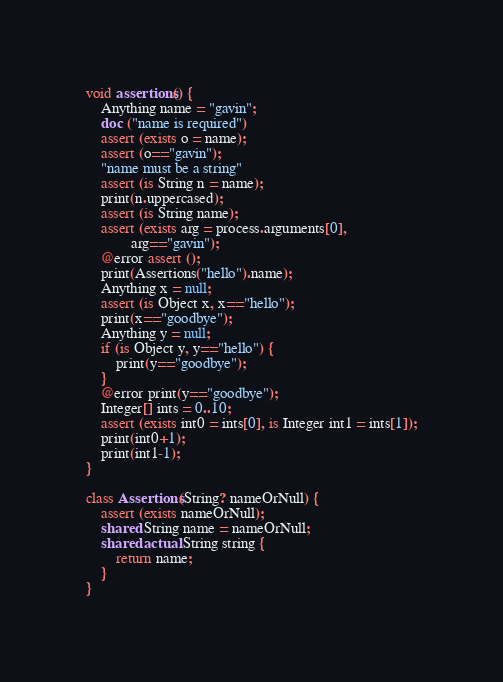<code> <loc_0><loc_0><loc_500><loc_500><_Ceylon_>void assertions() {
    Anything name = "gavin";
    doc ("name is required") 
    assert (exists o = name);
    assert (o=="gavin");
    "name must be a string"
    assert (is String n = name);
    print(n.uppercased);
    assert (is String name);
    assert (exists arg = process.arguments[0], 
            arg=="gavin");
    @error assert ();
    print(Assertions("hello").name);
    Anything x = null;
    assert (is Object x, x=="hello");
    print(x=="goodbye");
    Anything y = null;
    if (is Object y, y=="hello") {
        print(y=="goodbye");
    }
    @error print(y=="goodbye");
    Integer[] ints = 0..10;
    assert (exists int0 = ints[0], is Integer int1 = ints[1]);
    print(int0+1);
    print(int1-1);
}

class Assertions(String? nameOrNull) {
    assert (exists nameOrNull);
    shared String name = nameOrNull;
    shared actual String string {
        return name;
    }
}
</code> 